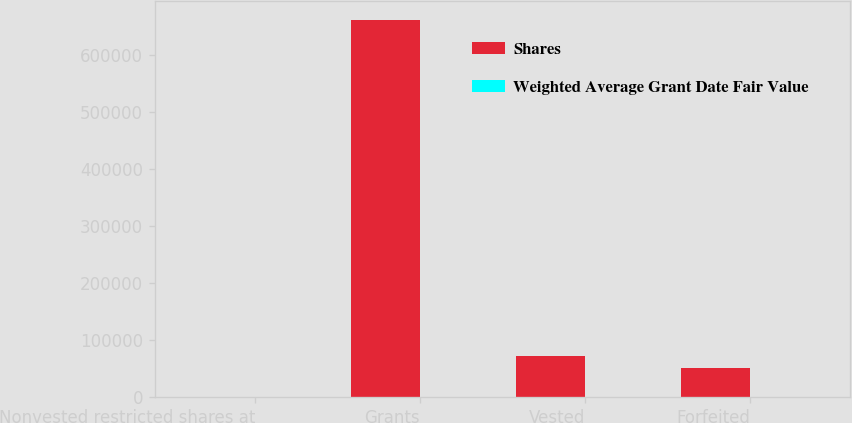<chart> <loc_0><loc_0><loc_500><loc_500><stacked_bar_chart><ecel><fcel>Nonvested restricted shares at<fcel>Grants<fcel>Vested<fcel>Forfeited<nl><fcel>Shares<fcel>61.65<fcel>661792<fcel>72744<fcel>51280<nl><fcel>Weighted Average Grant Date Fair Value<fcel>59.4<fcel>57.09<fcel>60.99<fcel>59.23<nl></chart> 